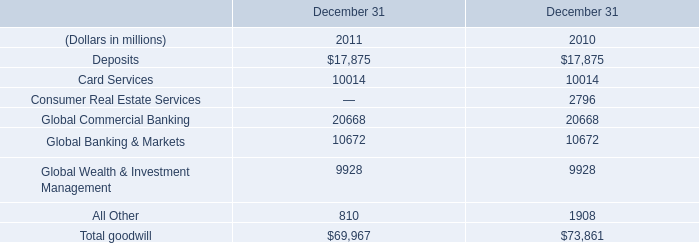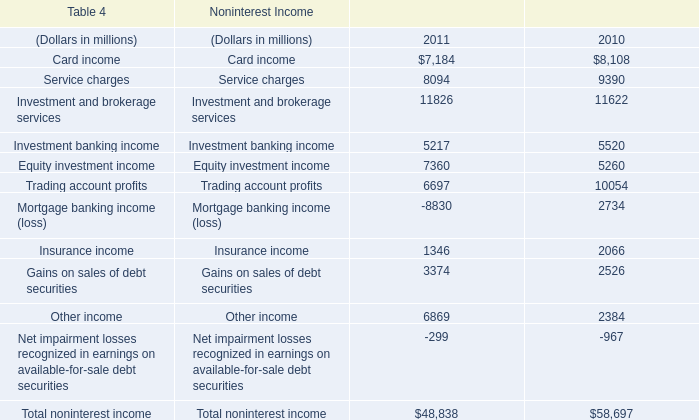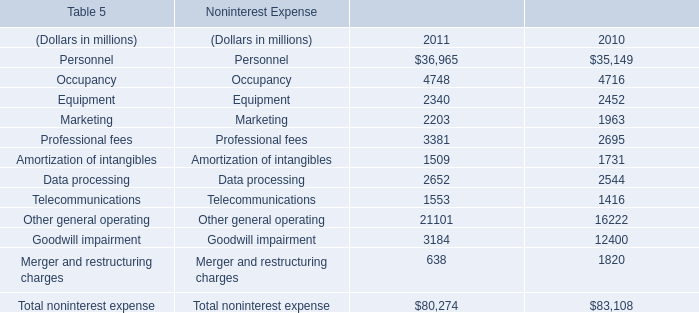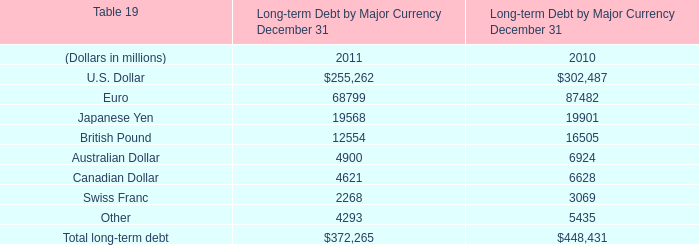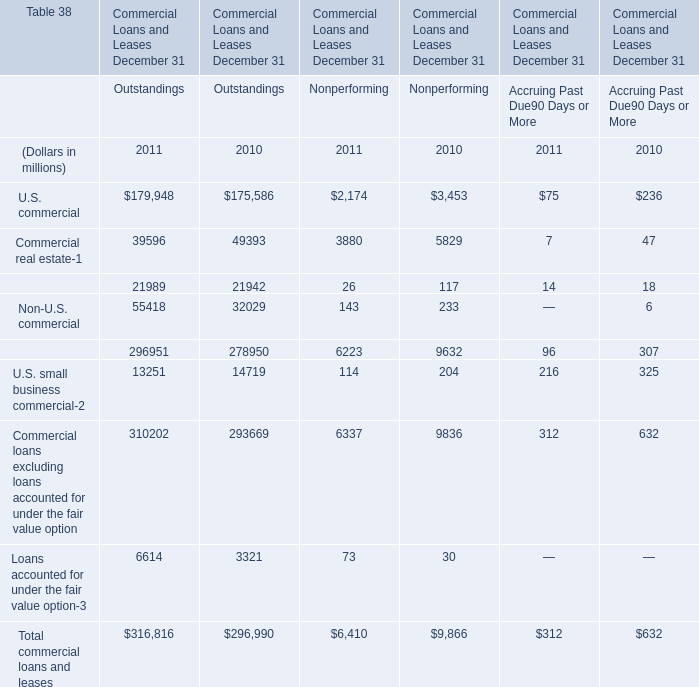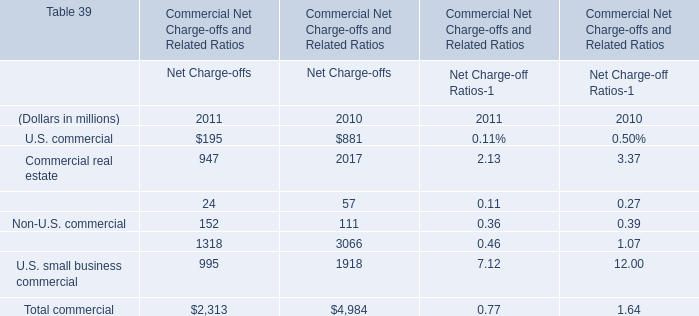What's the average of Other general operating of Noninterest Expense 2010, and Investment and brokerage services of Noninterest Income 2011 ? 
Computations: ((16222.0 + 11826.0) / 2)
Answer: 14024.0. 